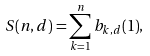Convert formula to latex. <formula><loc_0><loc_0><loc_500><loc_500>S ( n , d ) = \sum _ { k = 1 } ^ { n } { b _ { k , d } ( 1 ) } ,</formula> 